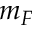Convert formula to latex. <formula><loc_0><loc_0><loc_500><loc_500>m _ { F }</formula> 